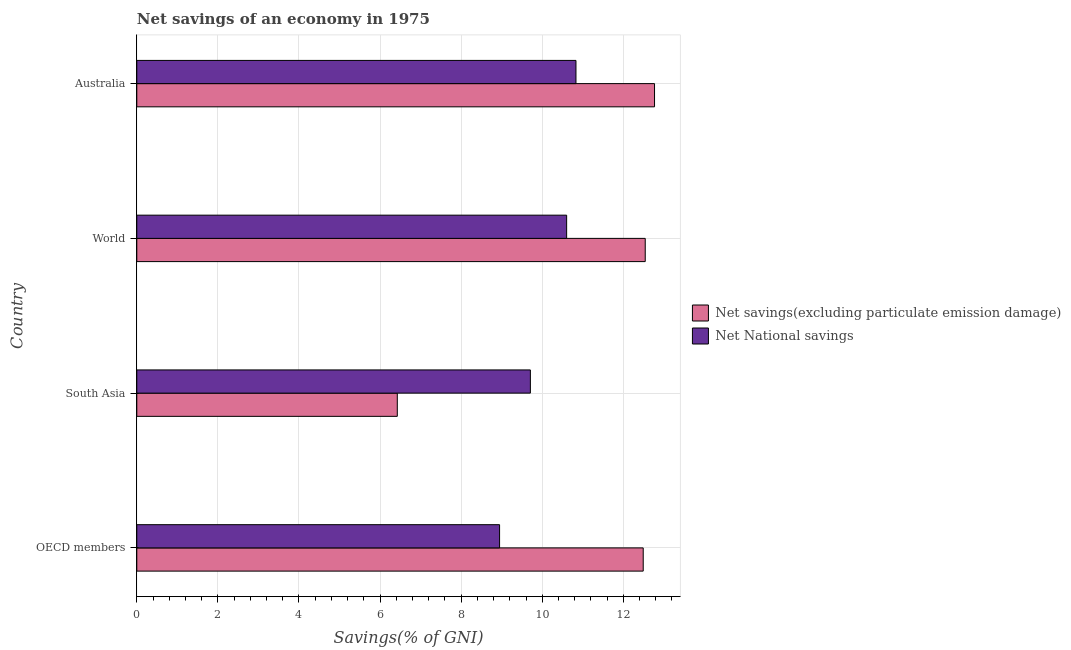How many different coloured bars are there?
Your response must be concise. 2. How many groups of bars are there?
Keep it short and to the point. 4. Are the number of bars per tick equal to the number of legend labels?
Your answer should be very brief. Yes. How many bars are there on the 4th tick from the top?
Provide a succinct answer. 2. How many bars are there on the 3rd tick from the bottom?
Make the answer very short. 2. What is the label of the 2nd group of bars from the top?
Ensure brevity in your answer.  World. What is the net national savings in South Asia?
Your response must be concise. 9.71. Across all countries, what is the maximum net savings(excluding particulate emission damage)?
Offer a very short reply. 12.77. Across all countries, what is the minimum net savings(excluding particulate emission damage)?
Offer a very short reply. 6.43. What is the total net savings(excluding particulate emission damage) in the graph?
Your response must be concise. 44.23. What is the difference between the net national savings in South Asia and that in World?
Ensure brevity in your answer.  -0.89. What is the difference between the net savings(excluding particulate emission damage) in South Asia and the net national savings in OECD members?
Provide a succinct answer. -2.52. What is the average net savings(excluding particulate emission damage) per country?
Provide a succinct answer. 11.06. What is the difference between the net savings(excluding particulate emission damage) and net national savings in Australia?
Ensure brevity in your answer.  1.94. What is the difference between the highest and the second highest net national savings?
Make the answer very short. 0.23. What is the difference between the highest and the lowest net national savings?
Offer a terse response. 1.88. What does the 2nd bar from the top in South Asia represents?
Keep it short and to the point. Net savings(excluding particulate emission damage). What does the 2nd bar from the bottom in Australia represents?
Offer a terse response. Net National savings. Are the values on the major ticks of X-axis written in scientific E-notation?
Provide a succinct answer. No. Does the graph contain grids?
Offer a terse response. Yes. Where does the legend appear in the graph?
Offer a very short reply. Center right. How are the legend labels stacked?
Ensure brevity in your answer.  Vertical. What is the title of the graph?
Your answer should be very brief. Net savings of an economy in 1975. Does "Education" appear as one of the legend labels in the graph?
Keep it short and to the point. No. What is the label or title of the X-axis?
Your answer should be compact. Savings(% of GNI). What is the label or title of the Y-axis?
Provide a succinct answer. Country. What is the Savings(% of GNI) in Net savings(excluding particulate emission damage) in OECD members?
Your answer should be very brief. 12.49. What is the Savings(% of GNI) of Net National savings in OECD members?
Give a very brief answer. 8.95. What is the Savings(% of GNI) of Net savings(excluding particulate emission damage) in South Asia?
Ensure brevity in your answer.  6.43. What is the Savings(% of GNI) of Net National savings in South Asia?
Ensure brevity in your answer.  9.71. What is the Savings(% of GNI) in Net savings(excluding particulate emission damage) in World?
Your response must be concise. 12.54. What is the Savings(% of GNI) in Net National savings in World?
Provide a short and direct response. 10.6. What is the Savings(% of GNI) of Net savings(excluding particulate emission damage) in Australia?
Your answer should be very brief. 12.77. What is the Savings(% of GNI) of Net National savings in Australia?
Offer a very short reply. 10.83. Across all countries, what is the maximum Savings(% of GNI) of Net savings(excluding particulate emission damage)?
Provide a short and direct response. 12.77. Across all countries, what is the maximum Savings(% of GNI) of Net National savings?
Keep it short and to the point. 10.83. Across all countries, what is the minimum Savings(% of GNI) of Net savings(excluding particulate emission damage)?
Provide a succinct answer. 6.43. Across all countries, what is the minimum Savings(% of GNI) of Net National savings?
Keep it short and to the point. 8.95. What is the total Savings(% of GNI) in Net savings(excluding particulate emission damage) in the graph?
Ensure brevity in your answer.  44.23. What is the total Savings(% of GNI) of Net National savings in the graph?
Offer a terse response. 40.09. What is the difference between the Savings(% of GNI) in Net savings(excluding particulate emission damage) in OECD members and that in South Asia?
Offer a very short reply. 6.07. What is the difference between the Savings(% of GNI) of Net National savings in OECD members and that in South Asia?
Your answer should be compact. -0.76. What is the difference between the Savings(% of GNI) in Net savings(excluding particulate emission damage) in OECD members and that in World?
Your answer should be very brief. -0.05. What is the difference between the Savings(% of GNI) in Net National savings in OECD members and that in World?
Your answer should be compact. -1.65. What is the difference between the Savings(% of GNI) of Net savings(excluding particulate emission damage) in OECD members and that in Australia?
Offer a very short reply. -0.28. What is the difference between the Savings(% of GNI) of Net National savings in OECD members and that in Australia?
Provide a succinct answer. -1.88. What is the difference between the Savings(% of GNI) of Net savings(excluding particulate emission damage) in South Asia and that in World?
Offer a terse response. -6.12. What is the difference between the Savings(% of GNI) of Net National savings in South Asia and that in World?
Make the answer very short. -0.89. What is the difference between the Savings(% of GNI) in Net savings(excluding particulate emission damage) in South Asia and that in Australia?
Your response must be concise. -6.34. What is the difference between the Savings(% of GNI) in Net National savings in South Asia and that in Australia?
Offer a terse response. -1.12. What is the difference between the Savings(% of GNI) in Net savings(excluding particulate emission damage) in World and that in Australia?
Provide a short and direct response. -0.23. What is the difference between the Savings(% of GNI) in Net National savings in World and that in Australia?
Keep it short and to the point. -0.23. What is the difference between the Savings(% of GNI) in Net savings(excluding particulate emission damage) in OECD members and the Savings(% of GNI) in Net National savings in South Asia?
Offer a terse response. 2.78. What is the difference between the Savings(% of GNI) in Net savings(excluding particulate emission damage) in OECD members and the Savings(% of GNI) in Net National savings in World?
Make the answer very short. 1.89. What is the difference between the Savings(% of GNI) of Net savings(excluding particulate emission damage) in OECD members and the Savings(% of GNI) of Net National savings in Australia?
Keep it short and to the point. 1.66. What is the difference between the Savings(% of GNI) in Net savings(excluding particulate emission damage) in South Asia and the Savings(% of GNI) in Net National savings in World?
Provide a succinct answer. -4.18. What is the difference between the Savings(% of GNI) of Net savings(excluding particulate emission damage) in South Asia and the Savings(% of GNI) of Net National savings in Australia?
Keep it short and to the point. -4.41. What is the difference between the Savings(% of GNI) of Net savings(excluding particulate emission damage) in World and the Savings(% of GNI) of Net National savings in Australia?
Your answer should be very brief. 1.71. What is the average Savings(% of GNI) of Net savings(excluding particulate emission damage) per country?
Make the answer very short. 11.06. What is the average Savings(% of GNI) of Net National savings per country?
Provide a succinct answer. 10.02. What is the difference between the Savings(% of GNI) in Net savings(excluding particulate emission damage) and Savings(% of GNI) in Net National savings in OECD members?
Provide a short and direct response. 3.54. What is the difference between the Savings(% of GNI) in Net savings(excluding particulate emission damage) and Savings(% of GNI) in Net National savings in South Asia?
Provide a succinct answer. -3.28. What is the difference between the Savings(% of GNI) in Net savings(excluding particulate emission damage) and Savings(% of GNI) in Net National savings in World?
Your answer should be compact. 1.94. What is the difference between the Savings(% of GNI) in Net savings(excluding particulate emission damage) and Savings(% of GNI) in Net National savings in Australia?
Provide a succinct answer. 1.94. What is the ratio of the Savings(% of GNI) in Net savings(excluding particulate emission damage) in OECD members to that in South Asia?
Provide a short and direct response. 1.94. What is the ratio of the Savings(% of GNI) of Net National savings in OECD members to that in South Asia?
Offer a very short reply. 0.92. What is the ratio of the Savings(% of GNI) in Net National savings in OECD members to that in World?
Your answer should be very brief. 0.84. What is the ratio of the Savings(% of GNI) in Net savings(excluding particulate emission damage) in OECD members to that in Australia?
Provide a succinct answer. 0.98. What is the ratio of the Savings(% of GNI) in Net National savings in OECD members to that in Australia?
Your answer should be compact. 0.83. What is the ratio of the Savings(% of GNI) in Net savings(excluding particulate emission damage) in South Asia to that in World?
Keep it short and to the point. 0.51. What is the ratio of the Savings(% of GNI) of Net National savings in South Asia to that in World?
Offer a terse response. 0.92. What is the ratio of the Savings(% of GNI) of Net savings(excluding particulate emission damage) in South Asia to that in Australia?
Provide a succinct answer. 0.5. What is the ratio of the Savings(% of GNI) in Net National savings in South Asia to that in Australia?
Make the answer very short. 0.9. What is the ratio of the Savings(% of GNI) in Net National savings in World to that in Australia?
Your answer should be compact. 0.98. What is the difference between the highest and the second highest Savings(% of GNI) of Net savings(excluding particulate emission damage)?
Your answer should be compact. 0.23. What is the difference between the highest and the second highest Savings(% of GNI) of Net National savings?
Ensure brevity in your answer.  0.23. What is the difference between the highest and the lowest Savings(% of GNI) in Net savings(excluding particulate emission damage)?
Ensure brevity in your answer.  6.34. What is the difference between the highest and the lowest Savings(% of GNI) of Net National savings?
Give a very brief answer. 1.88. 